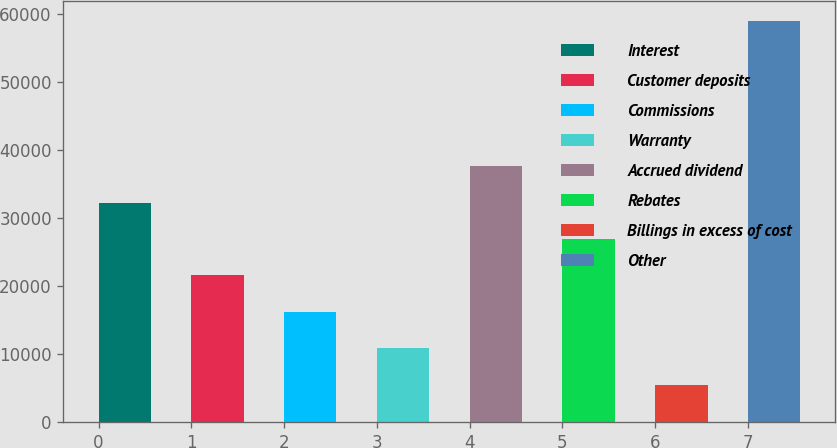<chart> <loc_0><loc_0><loc_500><loc_500><bar_chart><fcel>Interest<fcel>Customer deposits<fcel>Commissions<fcel>Warranty<fcel>Accrued dividend<fcel>Rebates<fcel>Billings in excess of cost<fcel>Other<nl><fcel>32217<fcel>21515.8<fcel>16165.2<fcel>10814.6<fcel>37567.6<fcel>26866.4<fcel>5464<fcel>58970<nl></chart> 